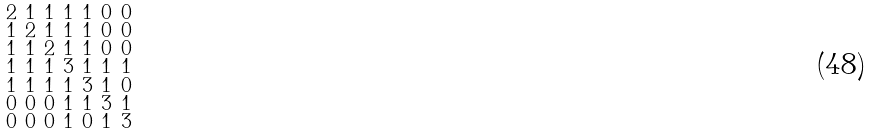<formula> <loc_0><loc_0><loc_500><loc_500>\begin{smallmatrix} 2 & 1 & 1 & 1 & 1 & 0 & 0 \\ 1 & 2 & 1 & 1 & 1 & 0 & 0 \\ 1 & 1 & 2 & 1 & 1 & 0 & 0 \\ 1 & 1 & 1 & 3 & 1 & 1 & 1 \\ 1 & 1 & 1 & 1 & 3 & 1 & 0 \\ 0 & 0 & 0 & 1 & 1 & 3 & 1 \\ 0 & 0 & 0 & 1 & 0 & 1 & 3 \end{smallmatrix}</formula> 